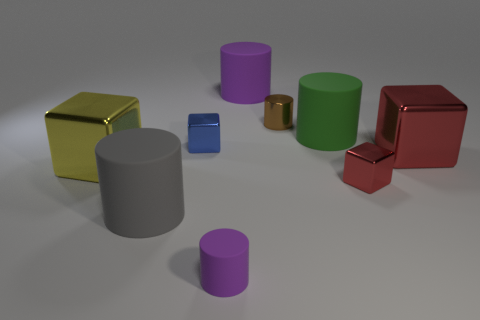Subtract all purple cylinders. How many cylinders are left? 3 Subtract all big gray rubber cylinders. How many cylinders are left? 4 Subtract 2 cylinders. How many cylinders are left? 3 Subtract all tiny cyan shiny cylinders. Subtract all large red cubes. How many objects are left? 8 Add 2 big green cylinders. How many big green cylinders are left? 3 Add 1 rubber cylinders. How many rubber cylinders exist? 5 Subtract 0 cyan spheres. How many objects are left? 9 Subtract all blocks. How many objects are left? 5 Subtract all purple cylinders. Subtract all red blocks. How many cylinders are left? 3 Subtract all cyan balls. How many gray blocks are left? 0 